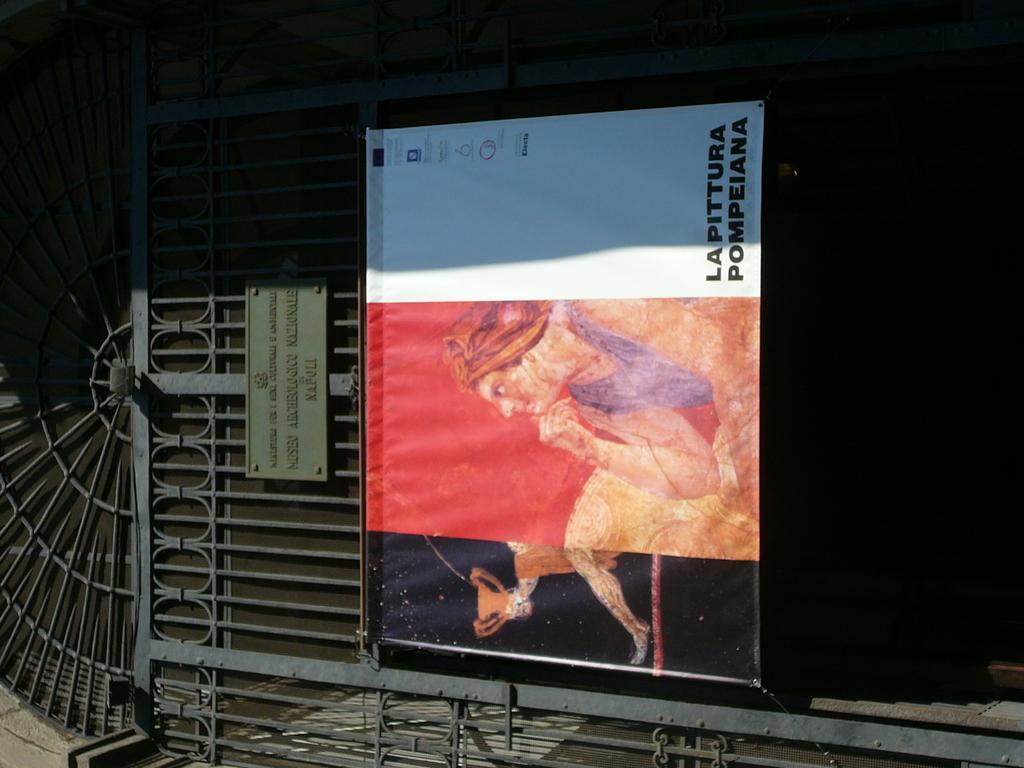What does it say on the flag?
Your answer should be very brief. Lapittura pompeiana. 